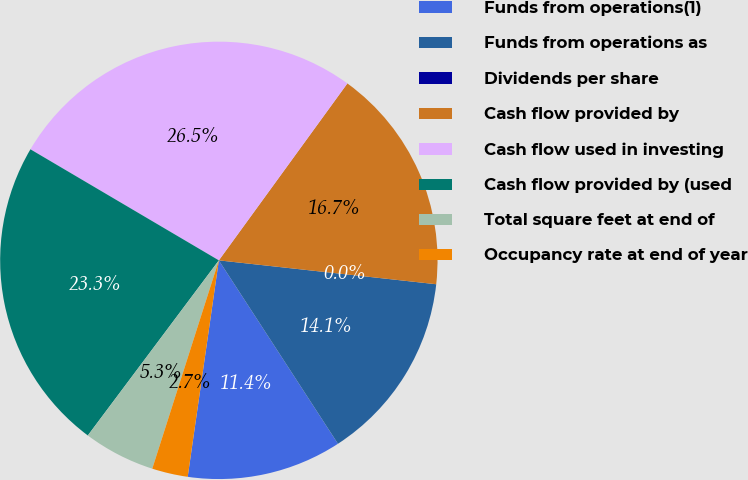<chart> <loc_0><loc_0><loc_500><loc_500><pie_chart><fcel>Funds from operations(1)<fcel>Funds from operations as<fcel>Dividends per share<fcel>Cash flow provided by<fcel>Cash flow used in investing<fcel>Cash flow provided by (used<fcel>Total square feet at end of<fcel>Occupancy rate at end of year<nl><fcel>11.44%<fcel>14.09%<fcel>0.0%<fcel>16.74%<fcel>26.52%<fcel>23.25%<fcel>5.3%<fcel>2.65%<nl></chart> 